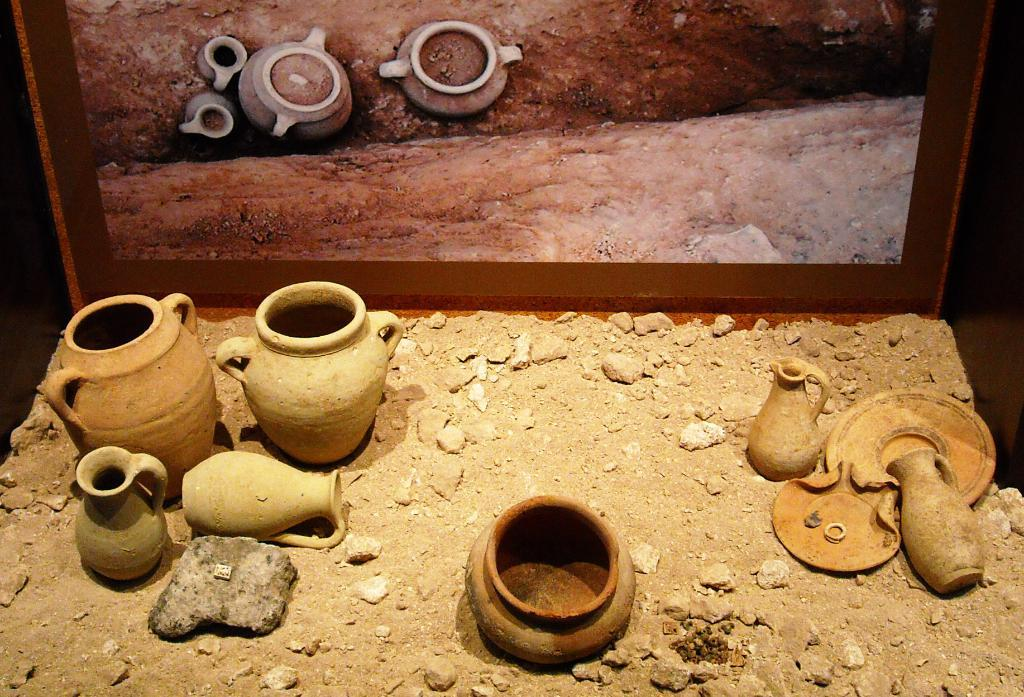What can be found at the bottom of the picture? There are mud pots at the bottom of the picture. What type of terrain is visible in the image? There is sand visible in the image. What is the background of the image? The background of the image appears to contain a photo frame. What is contained within the photo frame? The photo frame contains the mud pots and the soil. How many cherries are hanging from the mud pots in the image? There are no cherries present in the image; it features mud pots and sand. 